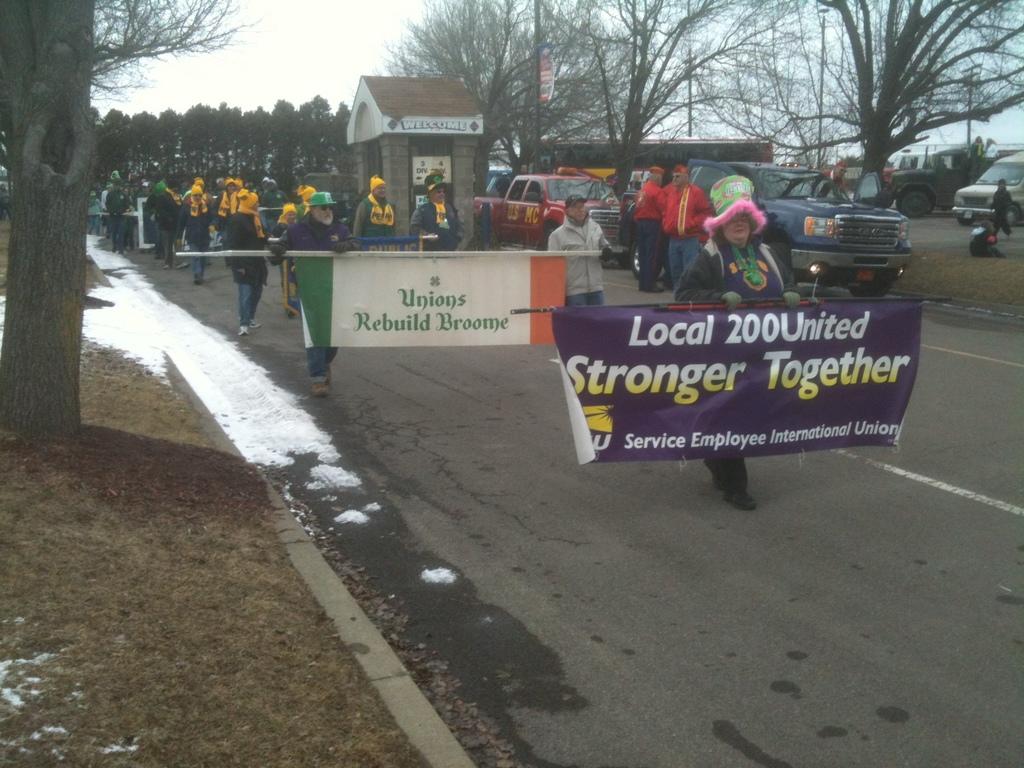Does the sign mention being stronger together?
Provide a short and direct response. Yes. 